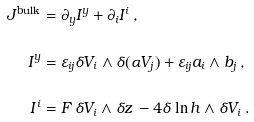<formula> <loc_0><loc_0><loc_500><loc_500>J ^ { \text {bulk} } & = \partial _ { y } I ^ { y } + \partial _ { i } I ^ { i } \, , \\ I ^ { y } & = \varepsilon _ { i j } \delta V _ { i } \wedge \delta ( \alpha V _ { j } ) + \varepsilon _ { i j } a _ { i } \wedge b _ { j } \, , \\ I ^ { i } & = F \, \delta V _ { i } \wedge \delta z \, - 4 \delta \ln h \wedge \delta V _ { i } \, .</formula> 